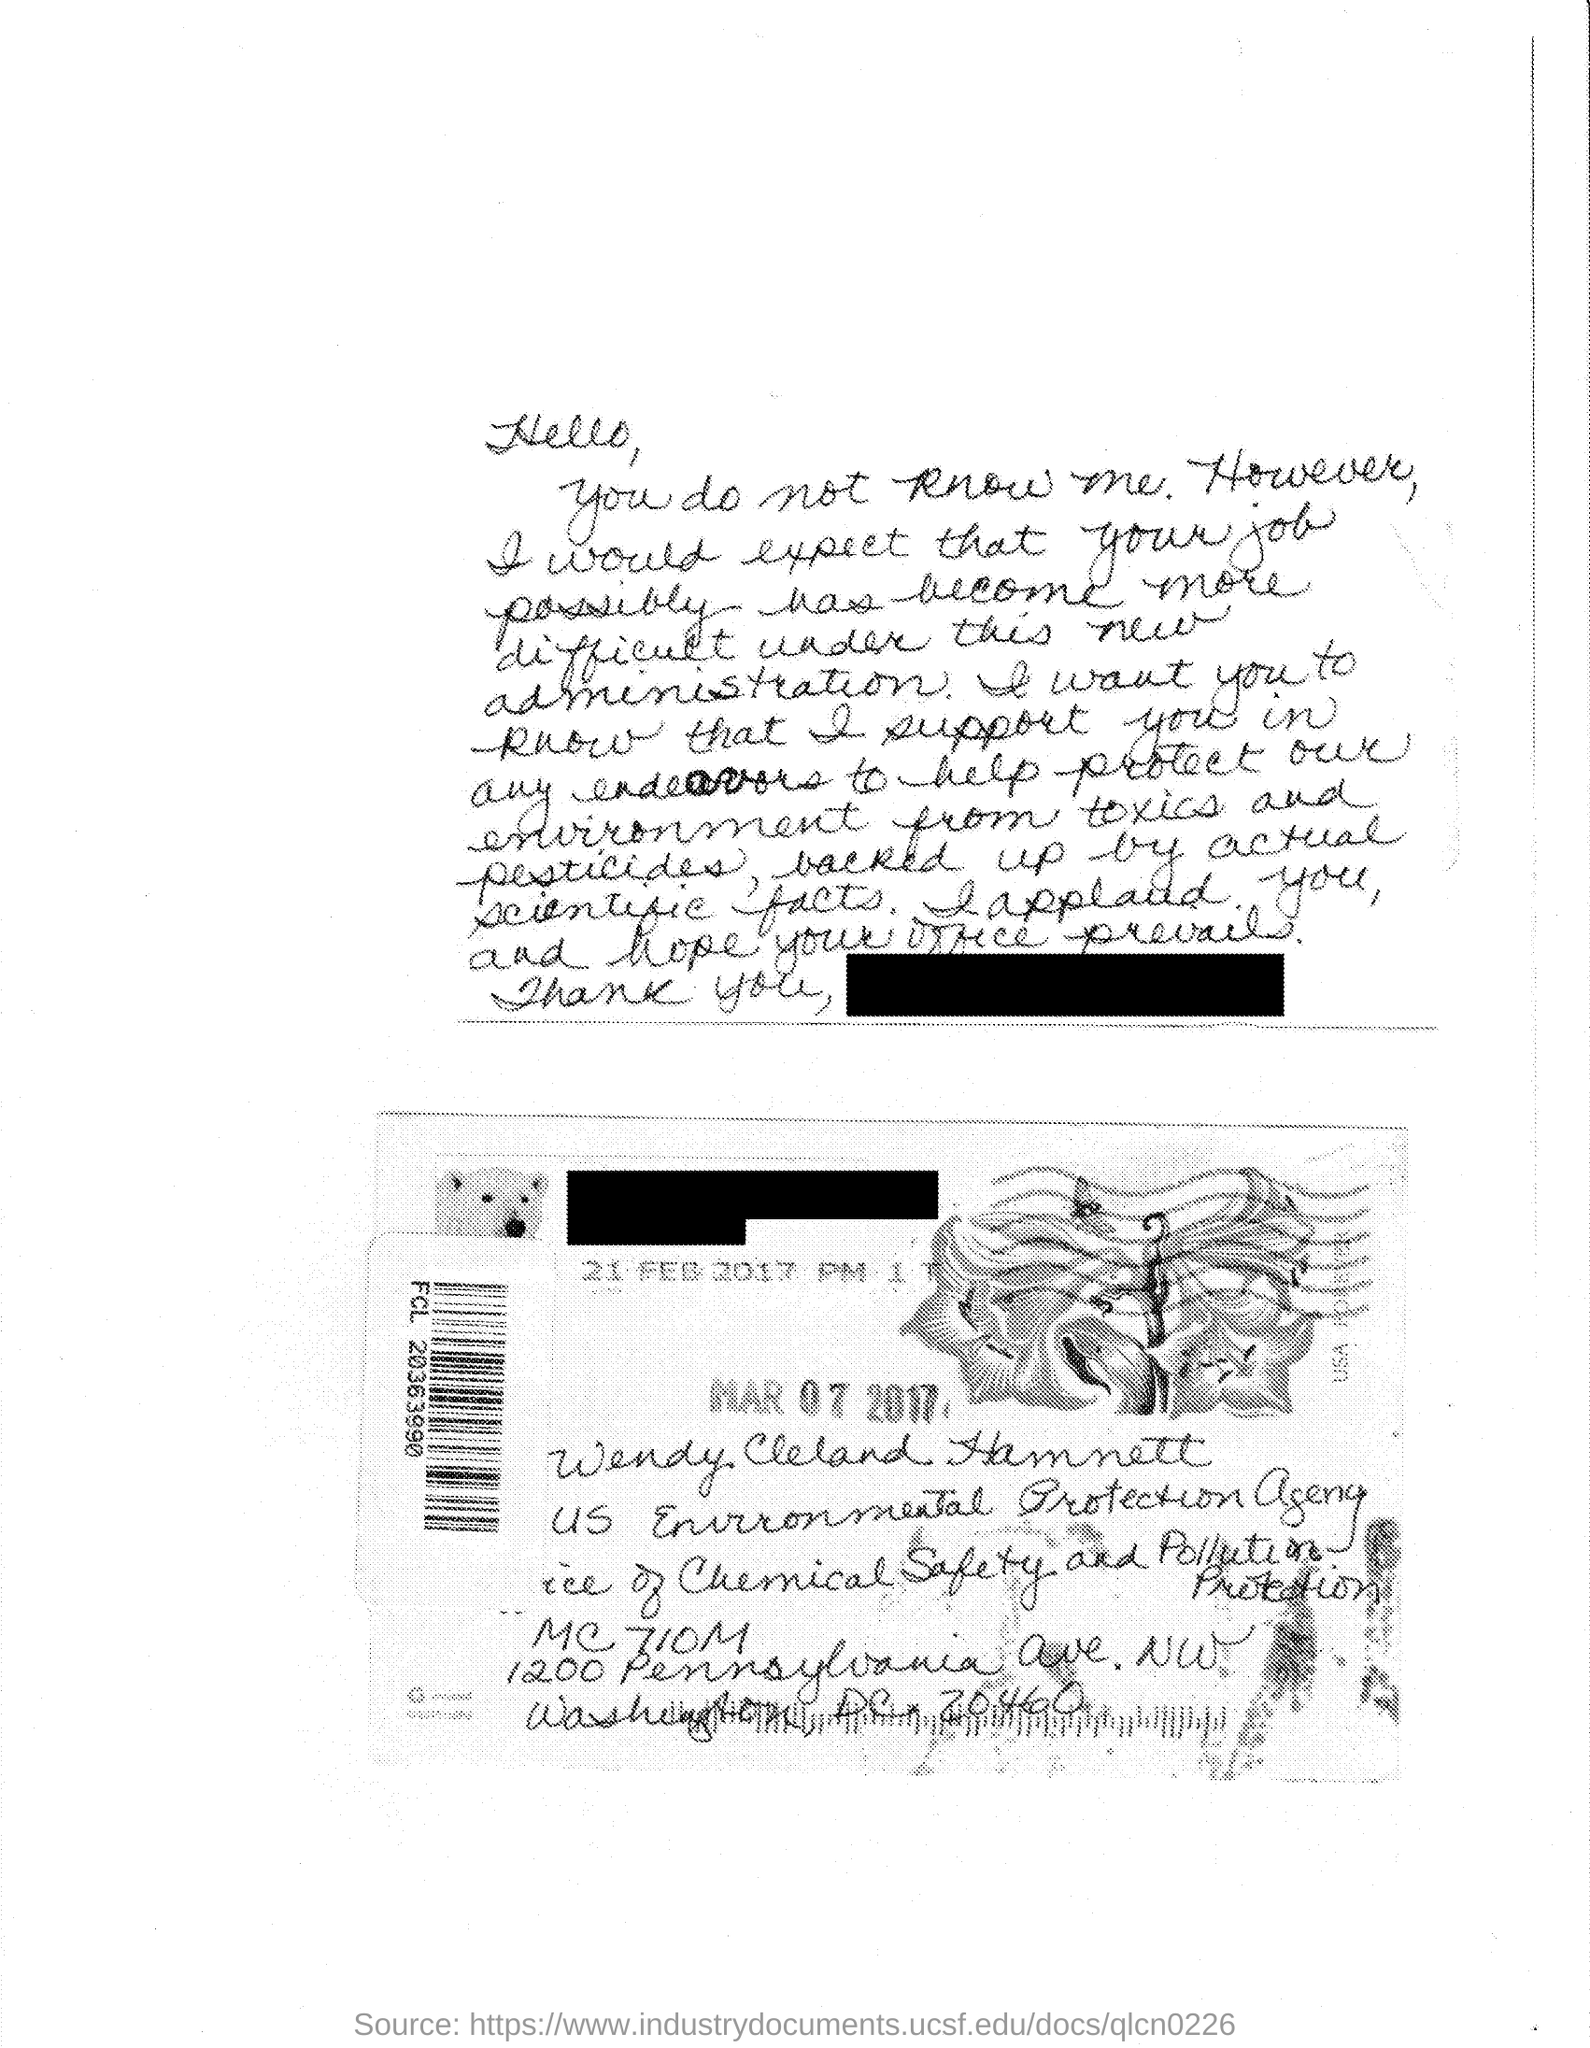What is the name of the person given in the address?
Give a very brief answer. Wendy Cleland Hamnett. In which agency, Wendy Cleland Hamnett works?
Make the answer very short. US Environmental Protection Agency. 